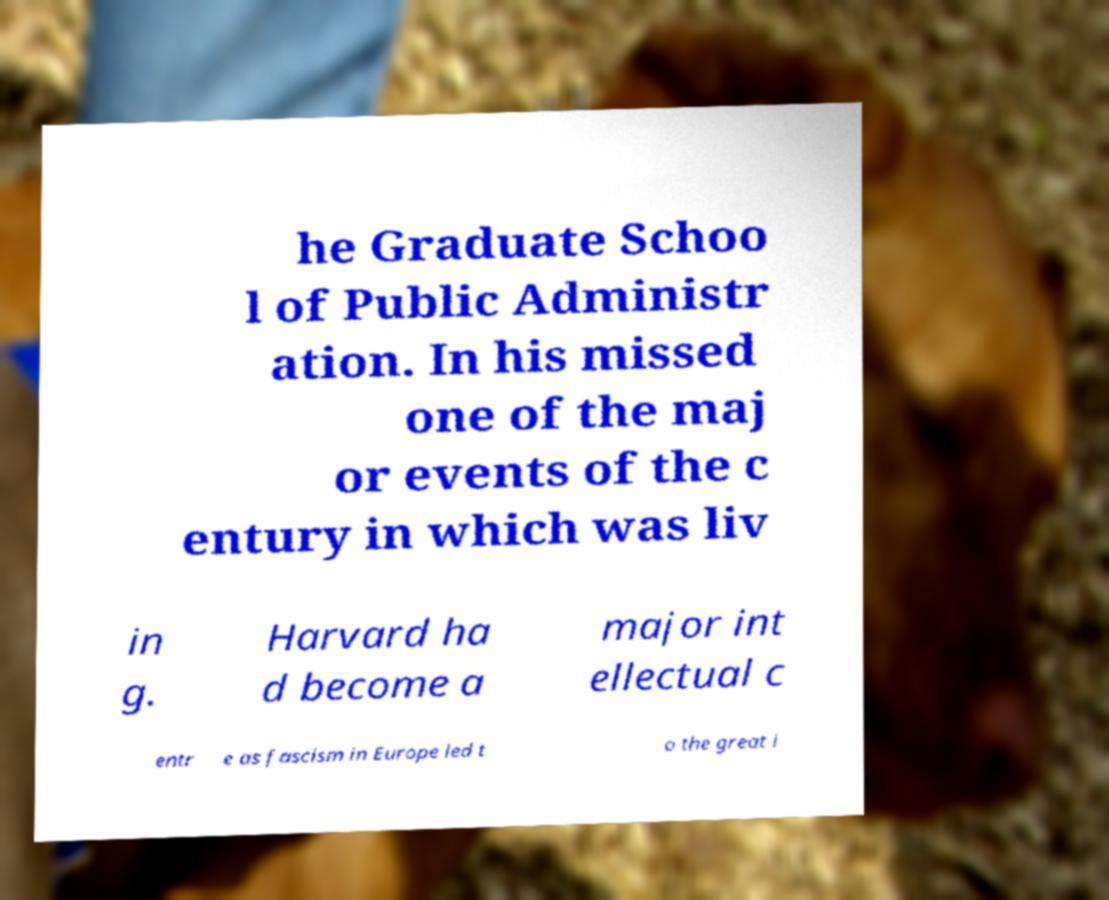Please read and relay the text visible in this image. What does it say? he Graduate Schoo l of Public Administr ation. In his missed one of the maj or events of the c entury in which was liv in g. Harvard ha d become a major int ellectual c entr e as fascism in Europe led t o the great i 